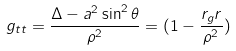Convert formula to latex. <formula><loc_0><loc_0><loc_500><loc_500>g _ { t t } = \frac { \Delta - a ^ { 2 } \sin ^ { 2 } \theta } { \rho ^ { 2 } } = ( 1 - \frac { r _ { g } r } { \rho ^ { 2 } } )</formula> 